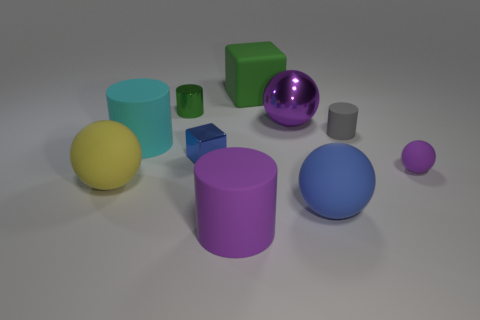Is there a small ball of the same color as the large rubber cube?
Give a very brief answer. No. There is a large green matte thing that is behind the purple matte thing left of the large sphere in front of the big yellow matte object; what is its shape?
Your answer should be compact. Cube. What is the material of the purple ball right of the tiny gray cylinder?
Make the answer very short. Rubber. How big is the cylinder to the right of the big purple object in front of the purple thing that is behind the cyan matte cylinder?
Provide a short and direct response. Small. Is the size of the cyan rubber object the same as the cylinder on the right side of the green block?
Make the answer very short. No. There is a matte object that is behind the tiny green object; what color is it?
Provide a succinct answer. Green. What is the shape of the other big object that is the same color as the big shiny thing?
Your answer should be very brief. Cylinder. What is the shape of the large blue object that is right of the yellow object?
Your answer should be very brief. Sphere. What number of purple objects are big balls or shiny cylinders?
Keep it short and to the point. 1. Is the material of the gray thing the same as the large blue object?
Keep it short and to the point. Yes. 